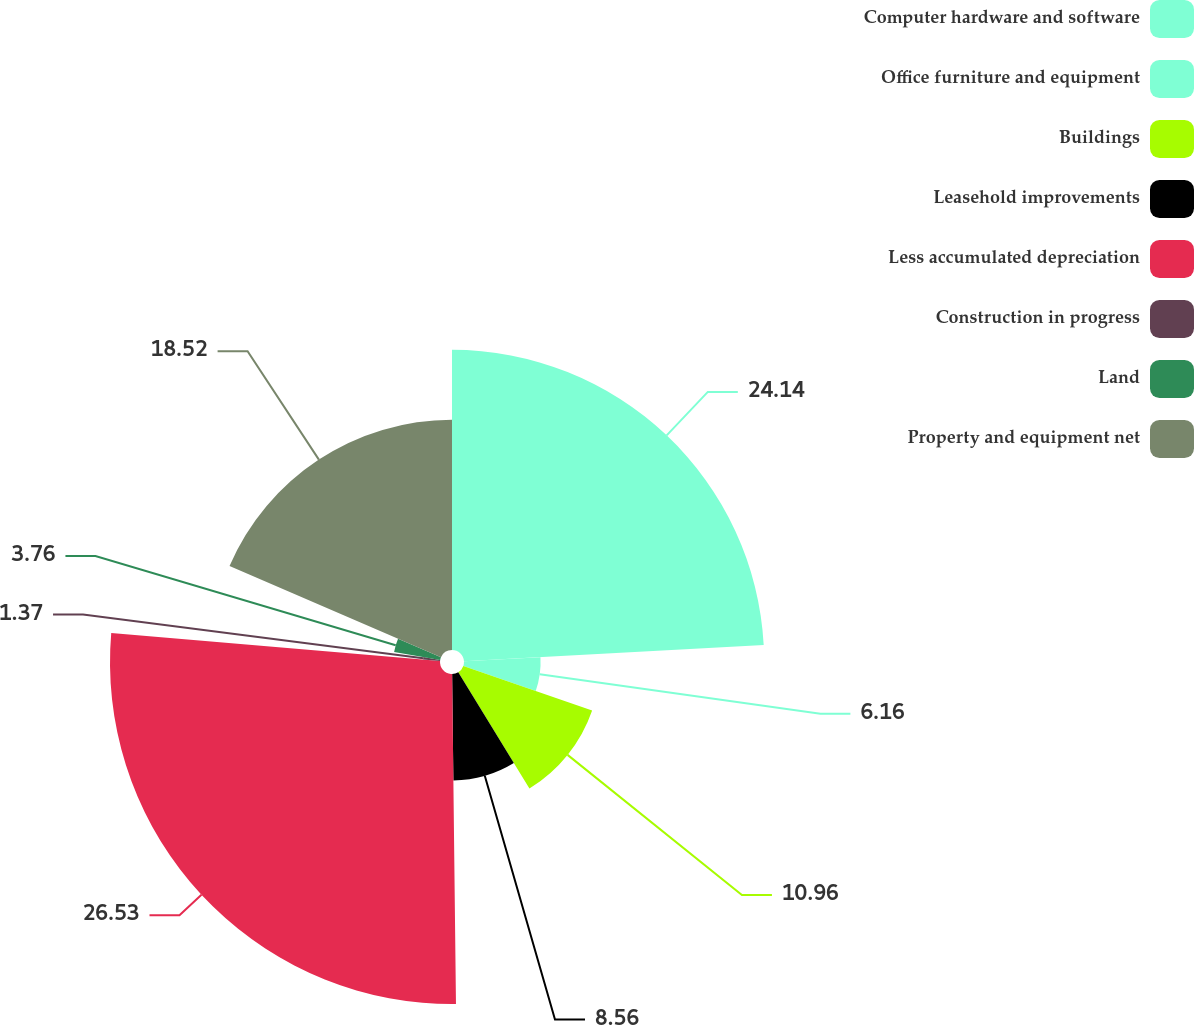<chart> <loc_0><loc_0><loc_500><loc_500><pie_chart><fcel>Computer hardware and software<fcel>Office furniture and equipment<fcel>Buildings<fcel>Leasehold improvements<fcel>Less accumulated depreciation<fcel>Construction in progress<fcel>Land<fcel>Property and equipment net<nl><fcel>24.14%<fcel>6.16%<fcel>10.96%<fcel>8.56%<fcel>26.54%<fcel>1.37%<fcel>3.76%<fcel>18.52%<nl></chart> 